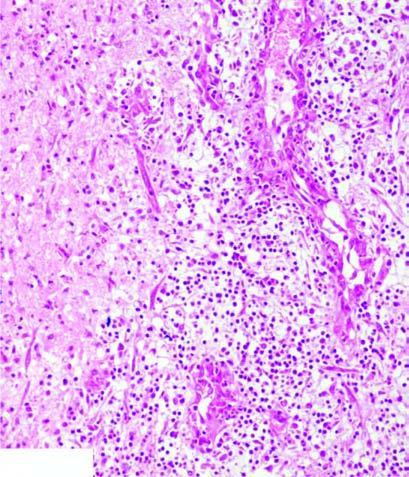does the necrosed area on right side of the field show a cystic space containing cell debris, while the surrounding zone shows granulation tissue and gliosis?
Answer the question using a single word or phrase. Yes 